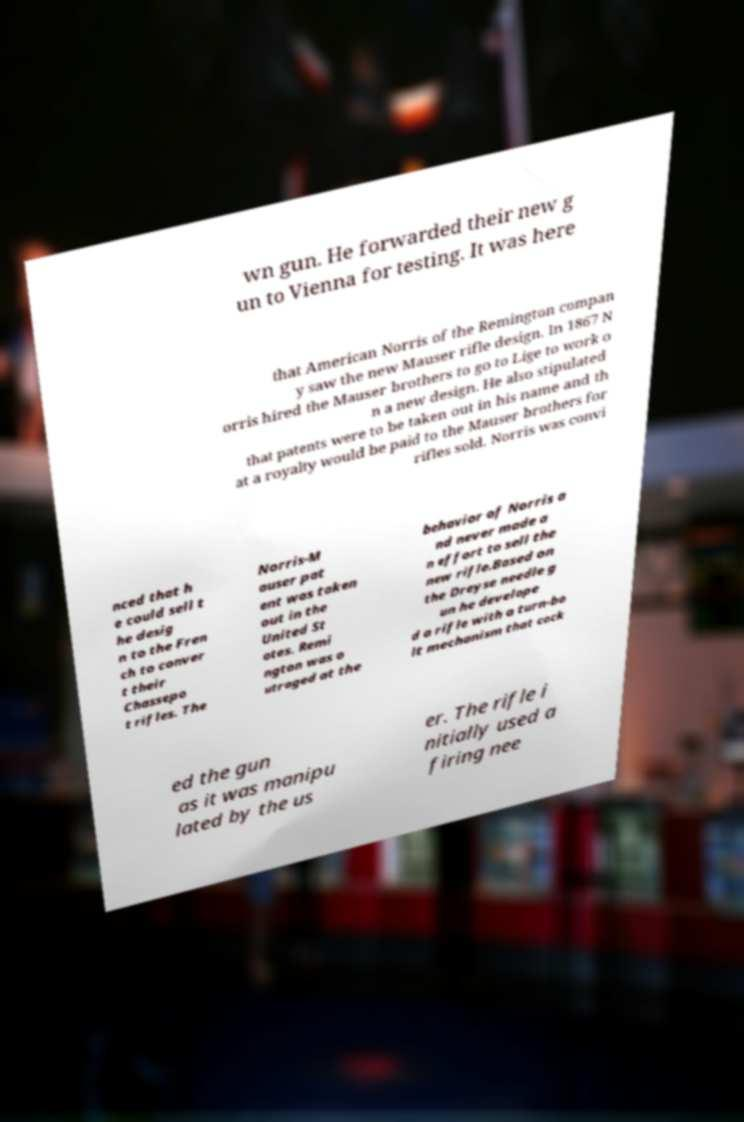Please read and relay the text visible in this image. What does it say? wn gun. He forwarded their new g un to Vienna for testing. It was here that American Norris of the Remington compan y saw the new Mauser rifle design. In 1867 N orris hired the Mauser brothers to go to Lige to work o n a new design. He also stipulated that patents were to be taken out in his name and th at a royalty would be paid to the Mauser brothers for rifles sold. Norris was convi nced that h e could sell t he desig n to the Fren ch to conver t their Chassepo t rifles. The Norris-M auser pat ent was taken out in the United St ates. Remi ngton was o utraged at the behavior of Norris a nd never made a n effort to sell the new rifle.Based on the Dreyse needle g un he develope d a rifle with a turn-bo lt mechanism that cock ed the gun as it was manipu lated by the us er. The rifle i nitially used a firing nee 